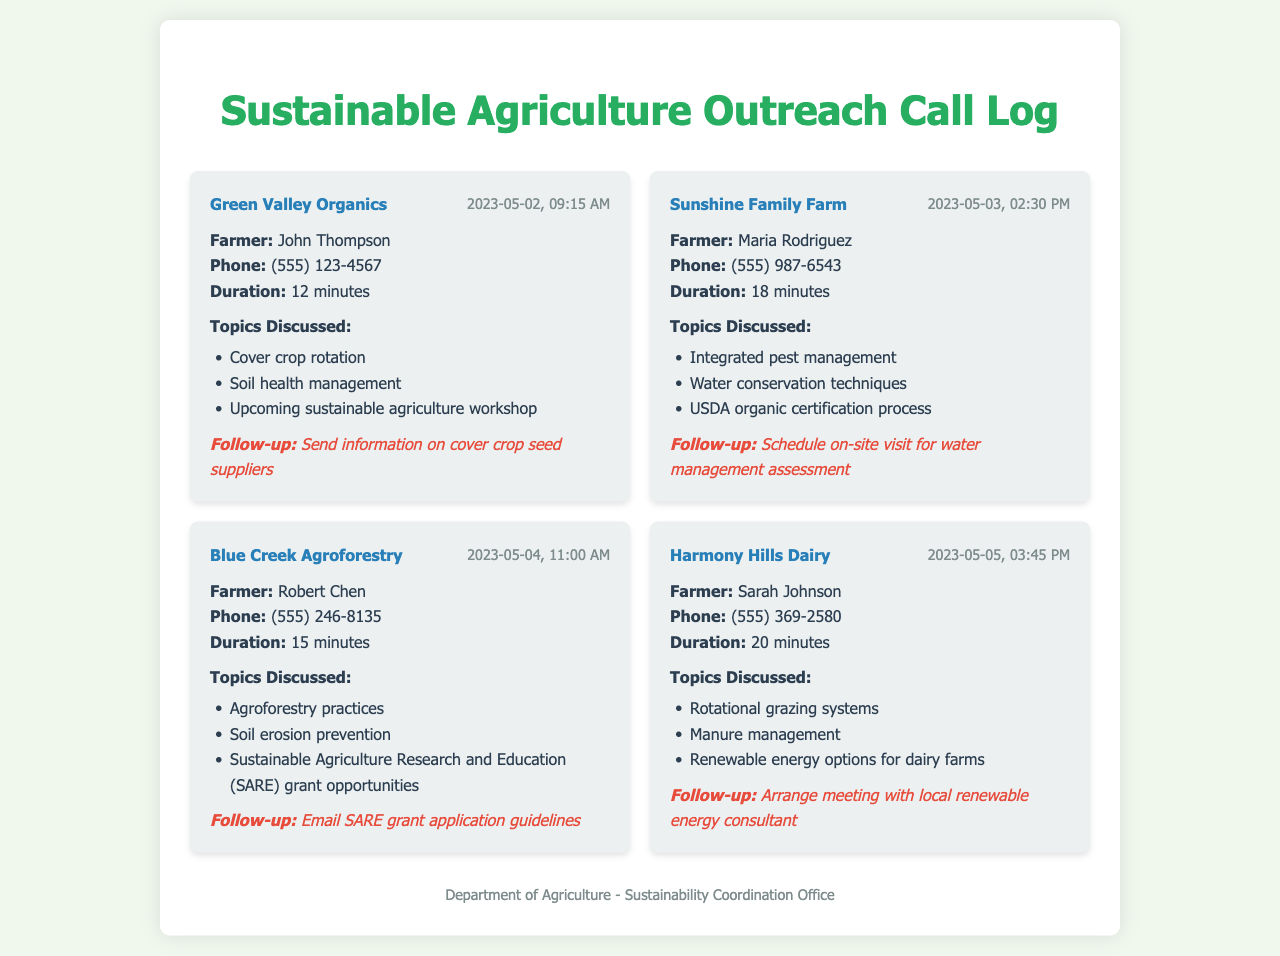What is the name of the farmer from Green Valley Organics? The farmer from Green Valley Organics is John Thompson, as mentioned in the call log.
Answer: John Thompson When was the call with Sunshine Family Farm made? The call with Sunshine Family Farm was made on May 3, 2023, at 02:30 PM, as indicated in the date-time section.
Answer: 2023-05-03, 02:30 PM How long was the call with Blue Creek Agroforestry? The duration of the call with Blue Creek Agroforestry was 15 minutes, according to the call entry details.
Answer: 15 minutes What topic did the call with Harmony Hills Dairy cover regarding energy options? The call with Harmony Hills Dairy discussed renewable energy options for dairy farms, as listed in the topics discussed.
Answer: Renewable energy options for dairy farms What is the follow-up action for the call with Maria Rodriguez? The follow-up action for the call with Maria Rodriguez is to schedule an on-site visit for a water management assessment, specified in the follow-up section.
Answer: Schedule on-site visit for water management assessment What was one grant opportunity mentioned during the call with Blue Creek Agroforestry? The grant opportunity mentioned during the call with Blue Creek Agroforestry was Sustainable Agriculture Research and Education (SARE) grant opportunities.
Answer: SARE grant opportunities How many minutes did the call with Harmony Hills Dairy last? The call with Harmony Hills Dairy lasted for 20 minutes, according to the duration information provided.
Answer: 20 minutes 